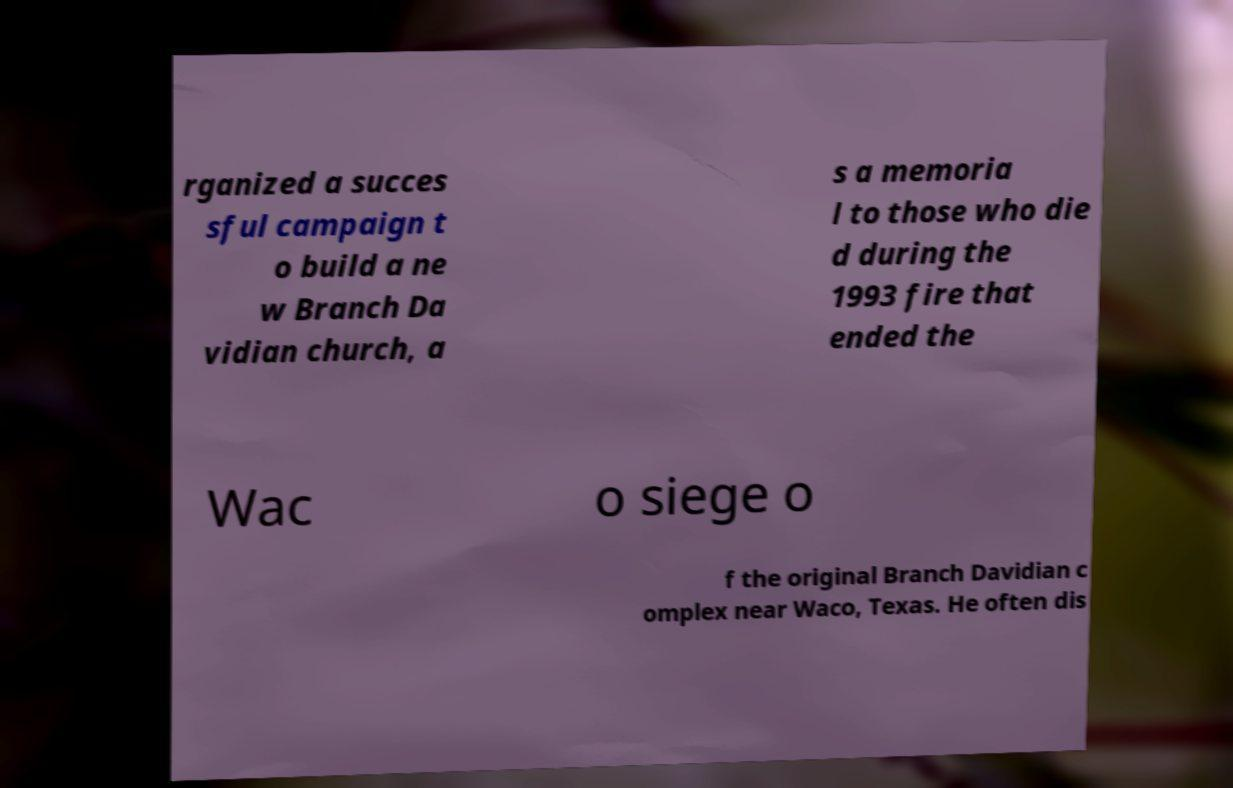I need the written content from this picture converted into text. Can you do that? rganized a succes sful campaign t o build a ne w Branch Da vidian church, a s a memoria l to those who die d during the 1993 fire that ended the Wac o siege o f the original Branch Davidian c omplex near Waco, Texas. He often dis 